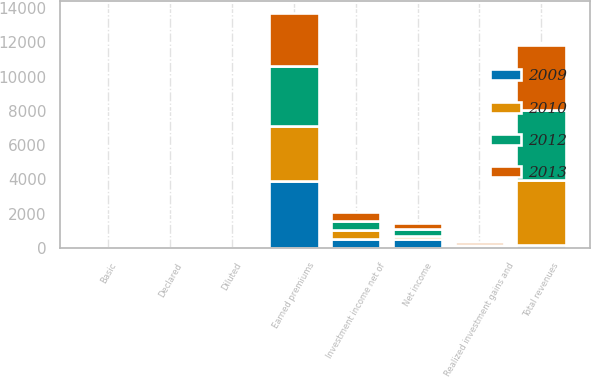<chart> <loc_0><loc_0><loc_500><loc_500><stacked_bar_chart><ecel><fcel>Earned premiums<fcel>Investment income net of<fcel>Realized investment gains and<fcel>Total revenues<fcel>Net income<fcel>Basic<fcel>Diluted<fcel>Declared<nl><fcel>2009<fcel>3902<fcel>529<fcel>83<fcel>159<fcel>517<fcel>3.16<fcel>3.12<fcel>1.66<nl><fcel>2012<fcel>3522<fcel>531<fcel>42<fcel>4111<fcel>421<fcel>2.59<fcel>2.57<fcel>1.62<nl><fcel>2010<fcel>3194<fcel>525<fcel>70<fcel>3803<fcel>164<fcel>1.01<fcel>1.01<fcel>1.6<nl><fcel>2013<fcel>3082<fcel>518<fcel>159<fcel>3772<fcel>375<fcel>2.3<fcel>2.3<fcel>1.59<nl></chart> 